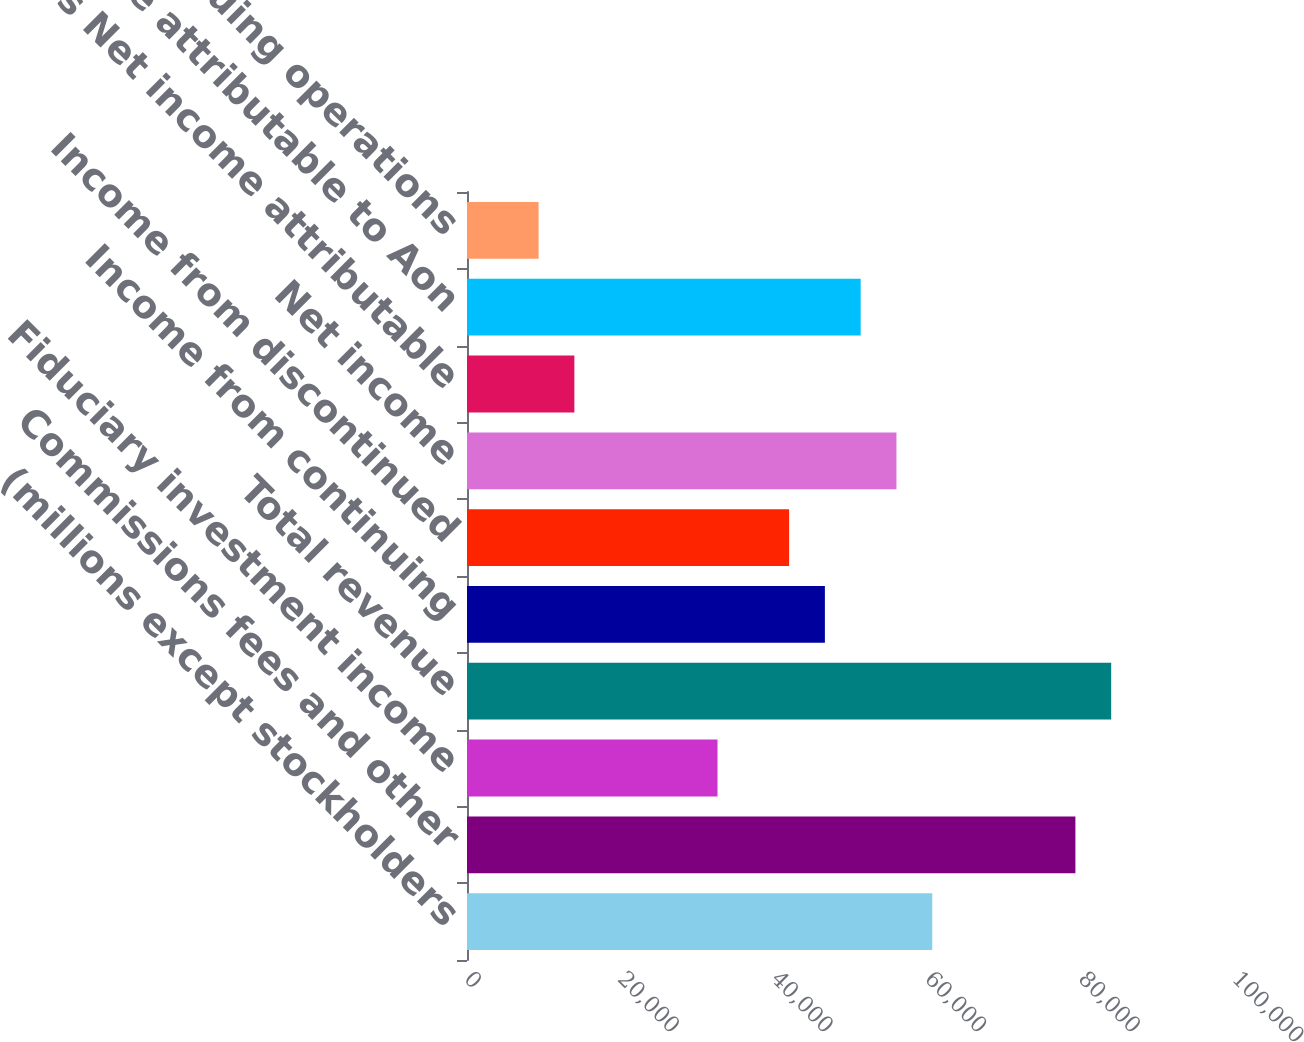<chart> <loc_0><loc_0><loc_500><loc_500><bar_chart><fcel>(millions except stockholders<fcel>Commissions fees and other<fcel>Fiduciary investment income<fcel>Total revenue<fcel>Income from continuing<fcel>Income from discontinued<fcel>Net income<fcel>Less Net income attributable<fcel>Net income attributable to Aon<fcel>Continuing operations<nl><fcel>60579.8<fcel>79219.6<fcel>32620.2<fcel>83879.5<fcel>46600<fcel>41940.1<fcel>55919.9<fcel>13980.4<fcel>51259.9<fcel>9320.48<nl></chart> 